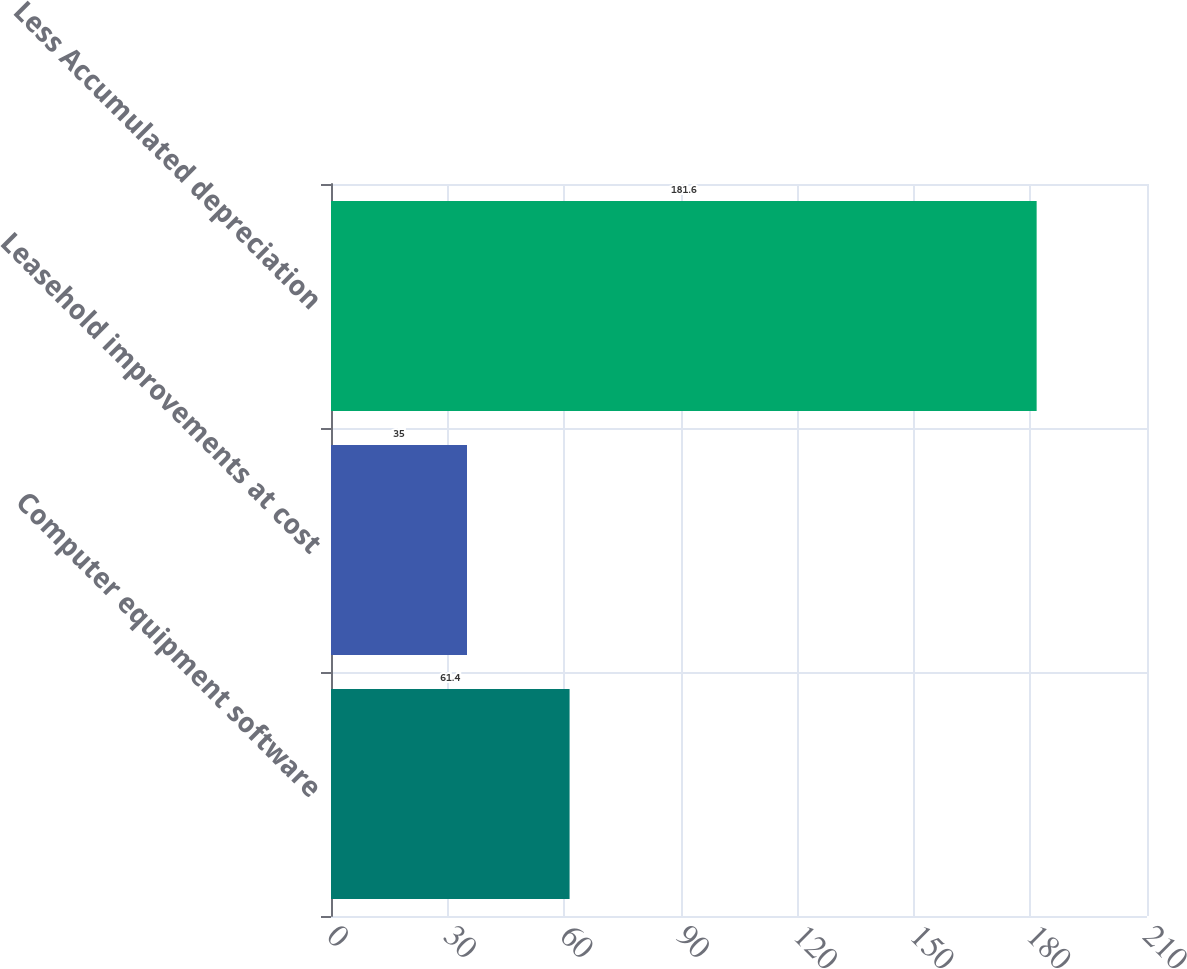<chart> <loc_0><loc_0><loc_500><loc_500><bar_chart><fcel>Computer equipment software<fcel>Leasehold improvements at cost<fcel>Less Accumulated depreciation<nl><fcel>61.4<fcel>35<fcel>181.6<nl></chart> 